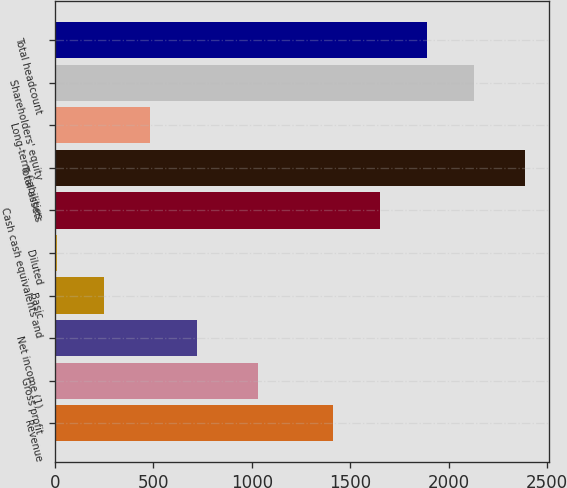<chart> <loc_0><loc_0><loc_500><loc_500><bar_chart><fcel>Revenue<fcel>Gross profit<fcel>Net income (1)<fcel>Basic<fcel>Diluted<fcel>Cash cash equivalents and<fcel>Total assets<fcel>Long-term liabilities<fcel>Shareholders' equity<fcel>Total headcount<nl><fcel>1413<fcel>1030<fcel>723.74<fcel>247.56<fcel>9.47<fcel>1651.09<fcel>2390.4<fcel>485.65<fcel>2127.27<fcel>1889.18<nl></chart> 